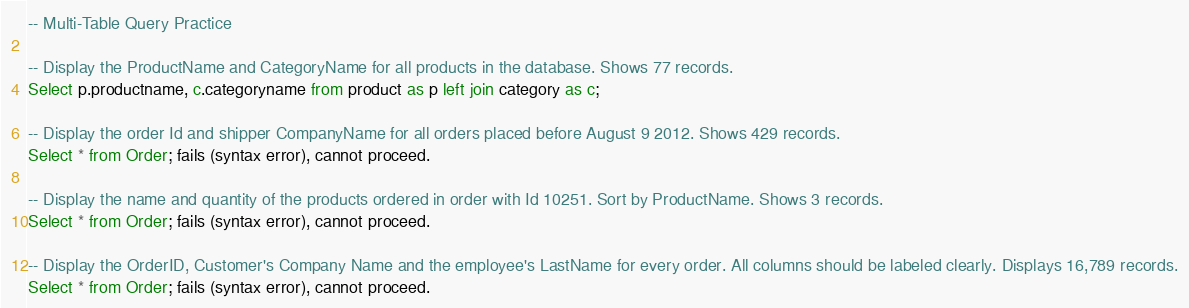Convert code to text. <code><loc_0><loc_0><loc_500><loc_500><_SQL_>-- Multi-Table Query Practice

-- Display the ProductName and CategoryName for all products in the database. Shows 77 records.
Select p.productname, c.categoryname from product as p left join category as c;

-- Display the order Id and shipper CompanyName for all orders placed before August 9 2012. Shows 429 records.
Select * from Order; fails (syntax error), cannot proceed.

-- Display the name and quantity of the products ordered in order with Id 10251. Sort by ProductName. Shows 3 records.
Select * from Order; fails (syntax error), cannot proceed.

-- Display the OrderID, Customer's Company Name and the employee's LastName for every order. All columns should be labeled clearly. Displays 16,789 records.
Select * from Order; fails (syntax error), cannot proceed.</code> 